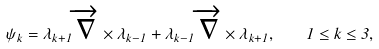<formula> <loc_0><loc_0><loc_500><loc_500>\psi _ { k } = \lambda _ { k + 1 } \overrightarrow { \nabla } \times \lambda _ { k - 1 } + \lambda _ { k - 1 } \overrightarrow { \nabla } \times \lambda _ { k + 1 } , \quad 1 \leq k \leq 3 ,</formula> 